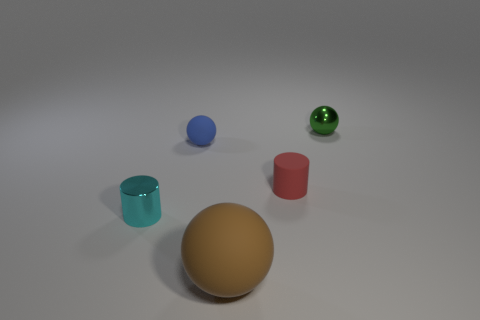Add 3 rubber things. How many objects exist? 8 Subtract all balls. How many objects are left? 2 Subtract all large green rubber cylinders. Subtract all tiny blue rubber things. How many objects are left? 4 Add 5 metallic balls. How many metallic balls are left? 6 Add 3 blue rubber balls. How many blue rubber balls exist? 4 Subtract 1 red cylinders. How many objects are left? 4 